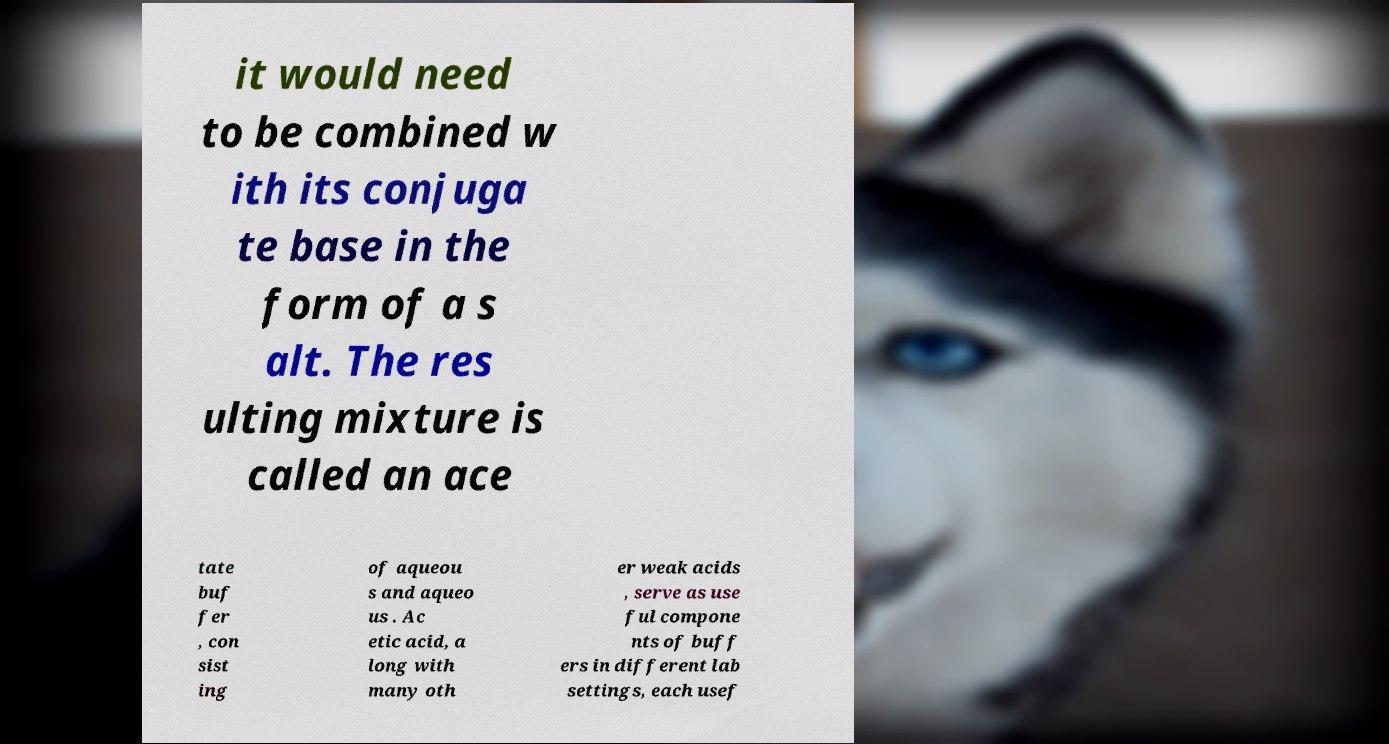What messages or text are displayed in this image? I need them in a readable, typed format. it would need to be combined w ith its conjuga te base in the form of a s alt. The res ulting mixture is called an ace tate buf fer , con sist ing of aqueou s and aqueo us . Ac etic acid, a long with many oth er weak acids , serve as use ful compone nts of buff ers in different lab settings, each usef 